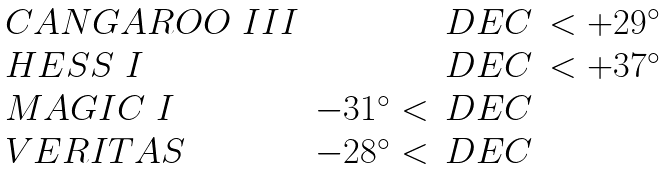Convert formula to latex. <formula><loc_0><loc_0><loc_500><loc_500>\begin{array} { l r c l } C A N G A R O O \ I I I & & D E C & < + 2 9 ^ { \circ } \\ H E S S \ I & & D E C & < + 3 7 ^ { \circ } \\ M A G I C \ I & - 3 1 ^ { \circ } < & D E C & \\ V E R I T A S & - 2 8 ^ { \circ } < & D E C & \\ \end{array}</formula> 